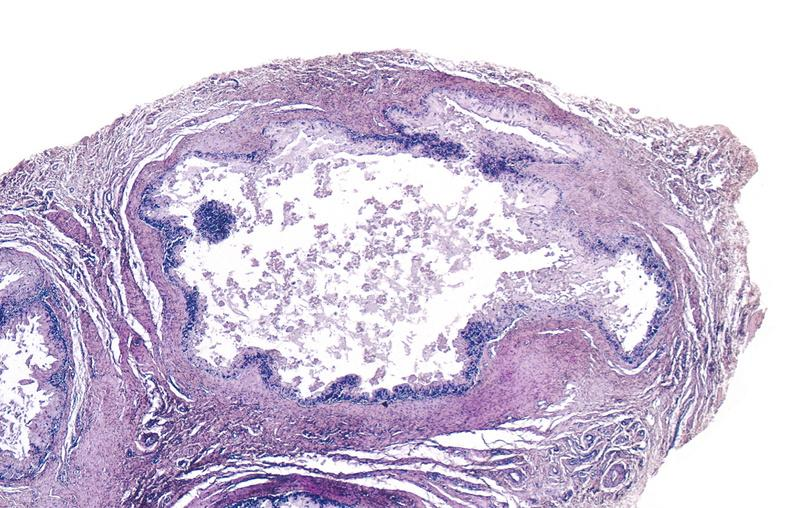does this image show gout?
Answer the question using a single word or phrase. Yes 